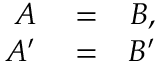Convert formula to latex. <formula><loc_0><loc_0><loc_500><loc_500>\begin{array} { r l r } { A } & = } & { B , } \\ { A ^ { \prime } } & = } & { B ^ { \prime } } \end{array}</formula> 